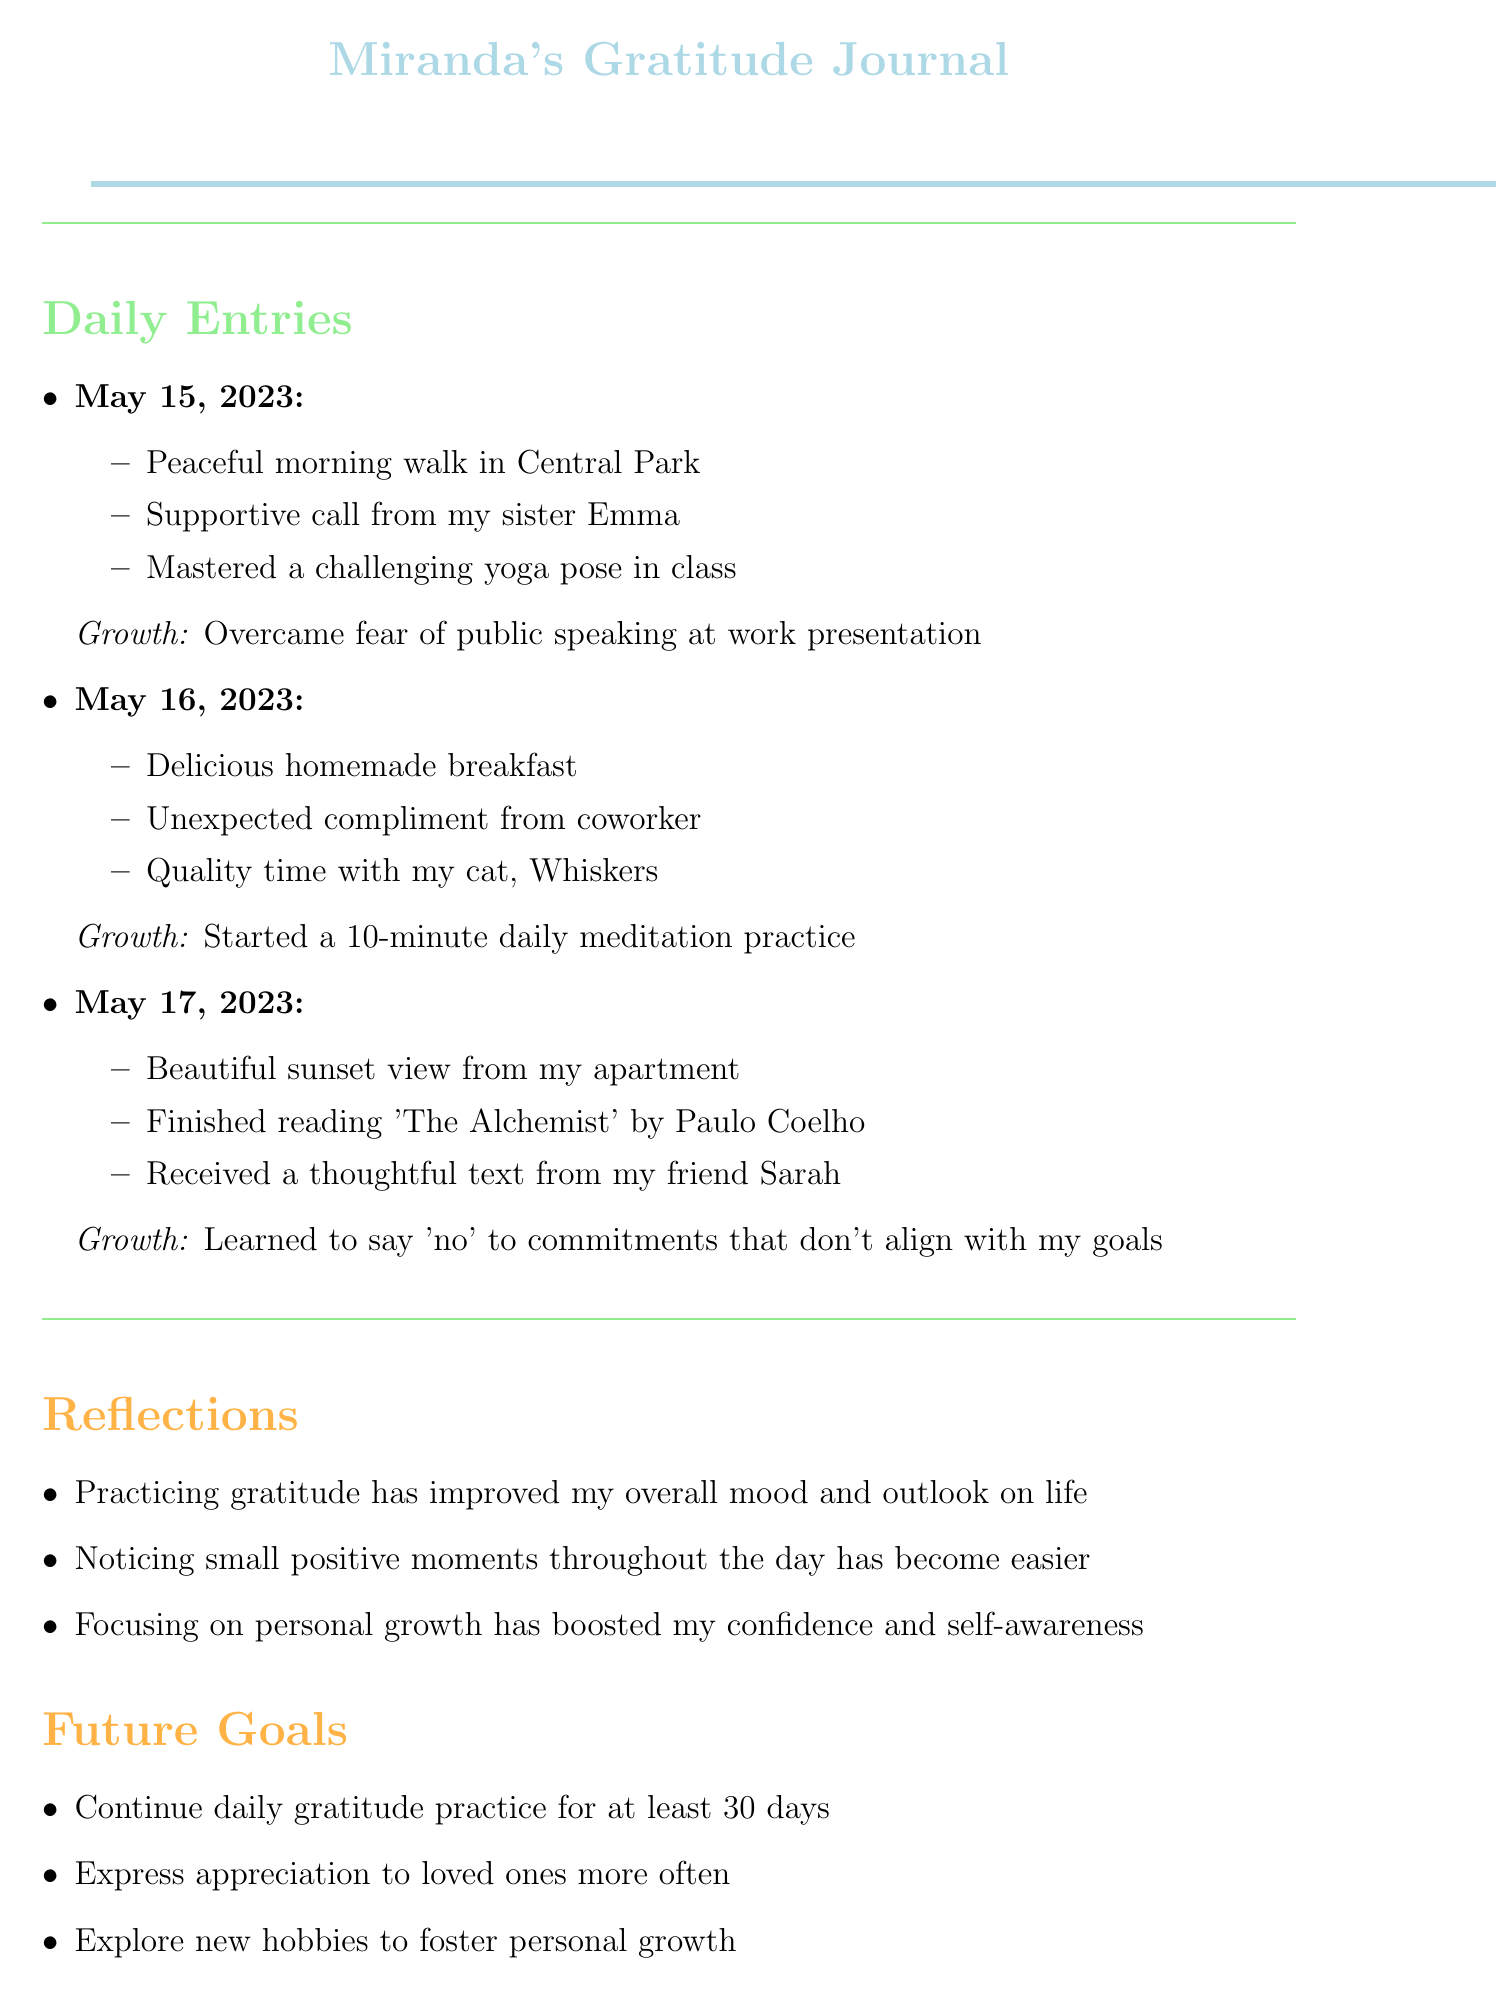What date did Miranda overcome her fear of public speaking? The date is mentioned in the journal entry about overcoming fear of public speaking, which is May 15, 2023.
Answer: May 15, 2023 What yoga pose did Miranda master? The specific yoga pose is mentioned in the gratitude items for May 15, 2023, but the name of the pose is not specified.
Answer: Challenging yoga pose What is one of Miranda's reflections about gratitude? The reflections section contains statements about the impact of gratitude on her mood and outlook. One notable statement is about overall mood improvement.
Answer: Improved mood How many days does Miranda aim to continue her gratitude practice? The future goals section states her intention to continue for at least 30 days.
Answer: 30 days Which book did Miranda finish reading? The journal entry for May 17, 2023, mentions the book she finished reading.
Answer: The Alchemist What does Miranda want to express more often to loved ones? In the future goals section, there is a specific mention of what she intends to do concerning her loved ones.
Answer: Appreciation On which date did Miranda spend quality time with her cat? The gratitude items for May 16, 2023, include spending time with her cat, providing the date of that entry.
Answer: May 16, 2023 What is one personal growth activity Miranda started? The journal entry for May 16, 2023, mentions a specific personal growth activity she began.
Answer: Daily meditation practice 